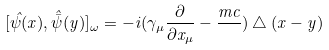<formula> <loc_0><loc_0><loc_500><loc_500>[ \hat { \psi } ( x ) , \hat { \bar { \psi } } ( y ) ] _ { \omega } = - i ( \gamma _ { \mu } \frac { \partial } { \partial x _ { \mu } } - \frac { m c } { } ) \bigtriangleup ( x - y )</formula> 